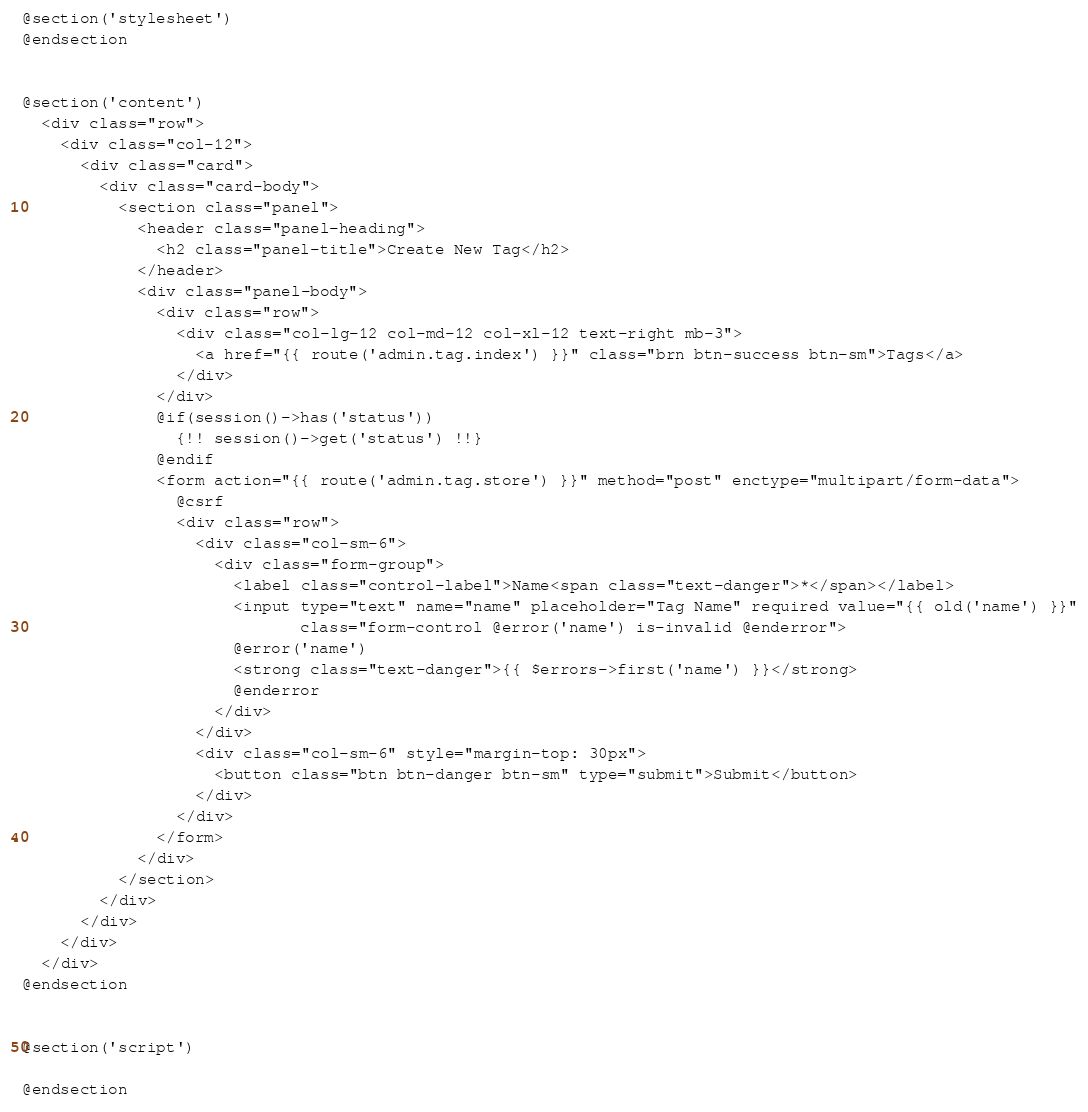Convert code to text. <code><loc_0><loc_0><loc_500><loc_500><_PHP_>
@section('stylesheet')
@endsection


@section('content')
  <div class="row">
    <div class="col-12">
      <div class="card">
        <div class="card-body">
          <section class="panel">
            <header class="panel-heading">
              <h2 class="panel-title">Create New Tag</h2>
            </header>
            <div class="panel-body">
              <div class="row">
                <div class="col-lg-12 col-md-12 col-xl-12 text-right mb-3">
                  <a href="{{ route('admin.tag.index') }}" class="brn btn-success btn-sm">Tags</a>
                </div>
              </div>
              @if(session()->has('status'))
                {!! session()->get('status') !!}
              @endif
              <form action="{{ route('admin.tag.store') }}" method="post" enctype="multipart/form-data">
                @csrf
                <div class="row">
                  <div class="col-sm-6">
                    <div class="form-group">
                      <label class="control-label">Name<span class="text-danger">*</span></label>
                      <input type="text" name="name" placeholder="Tag Name" required value="{{ old('name') }}"
                             class="form-control @error('name') is-invalid @enderror">
                      @error('name')
                      <strong class="text-danger">{{ $errors->first('name') }}</strong>
                      @enderror
                    </div>
                  </div>
                  <div class="col-sm-6" style="margin-top: 30px">
                    <button class="btn btn-danger btn-sm" type="submit">Submit</button>
                  </div>
                </div>
              </form>
            </div>
          </section>
        </div>
      </div>
    </div>
  </div>
@endsection


@section('script')

@endsection</code> 